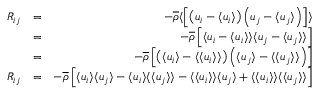Convert formula to latex. <formula><loc_0><loc_0><loc_500><loc_500>\begin{array} { r l r } { R _ { i j } } & { = } & { - \overline { \rho } \langle \left [ \left ( u _ { i } - \langle u _ { i } \rangle \right ) \left ( u _ { j } - \langle u _ { j } \rangle \right ) \right ] \rangle } \\ & { = } & { - \overline { \rho } \left [ \langle u _ { i } - \langle u _ { i } \rangle \rangle \langle u _ { j } - \langle u _ { j } \rangle \rangle \right ] } \\ & { = } & { - \overline { \rho } \left [ \left ( \langle u _ { i } \rangle - \langle \langle u _ { i } \rangle \rangle \right ) \left ( \langle u _ { j } \rangle - \langle \langle u _ { j } \rangle \rangle \right ) \right ] } \\ { R _ { i j } } & { = } & { - \overline { \rho } \left [ \langle u _ { i } \rangle \langle u _ { j } \rangle - \langle u _ { i } \rangle \langle \langle u _ { j } \rangle \rangle - \langle \langle u _ { i } \rangle \rangle \langle u _ { j } \rangle + \langle \langle u _ { i } \rangle \rangle \langle \langle u _ { j } \rangle \rangle \right ] } \end{array}</formula> 